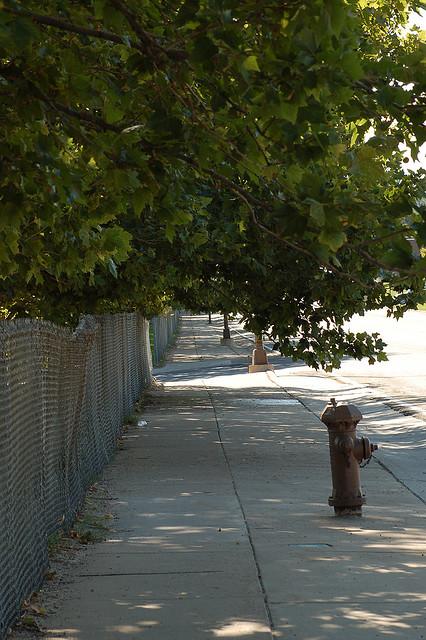How many fire hydrants are pictured? There is 1 fire hydrant pictured, prominently standing by the sidewalk, with its red hue contrasting against the grey pavement. 